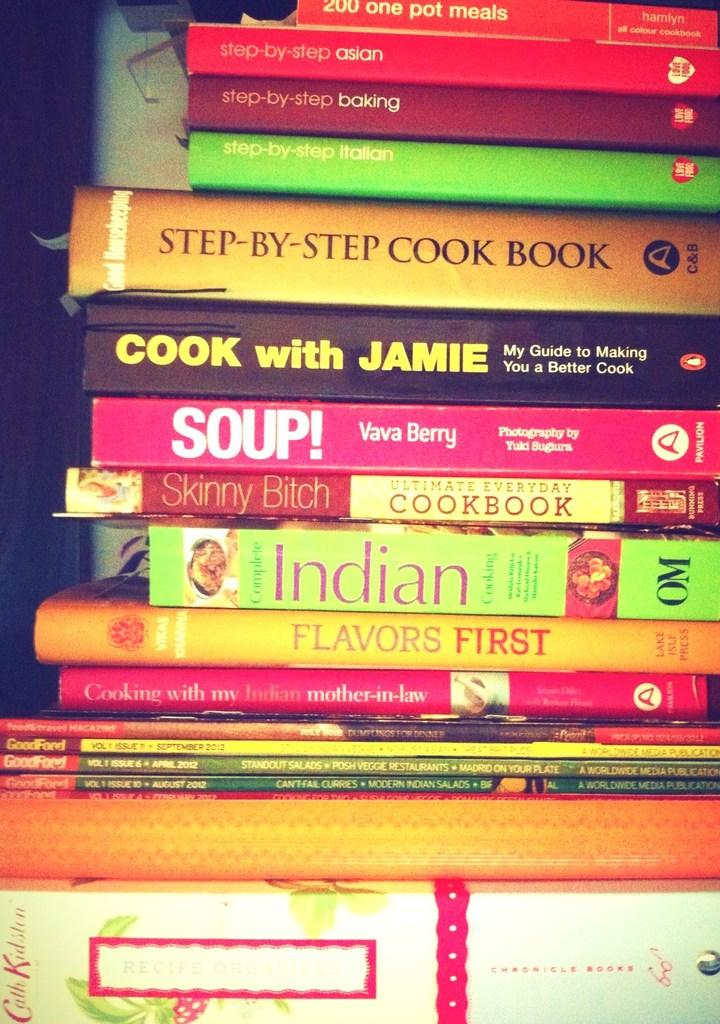What objects can be seen in the image? There are books in the image. What can be observed on the books? There is writing on the books. Can you describe the lighting in the image? The image appears to be dark. What type of wrist can be seen on the throne in the image? There is no wrist or throne present in the image; it only features books with writing on them. 